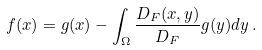Convert formula to latex. <formula><loc_0><loc_0><loc_500><loc_500>f ( x ) = g ( x ) - \int _ { \Omega } \frac { D _ { F } ( x , y ) } { D _ { F } } g ( y ) d y \, .</formula> 